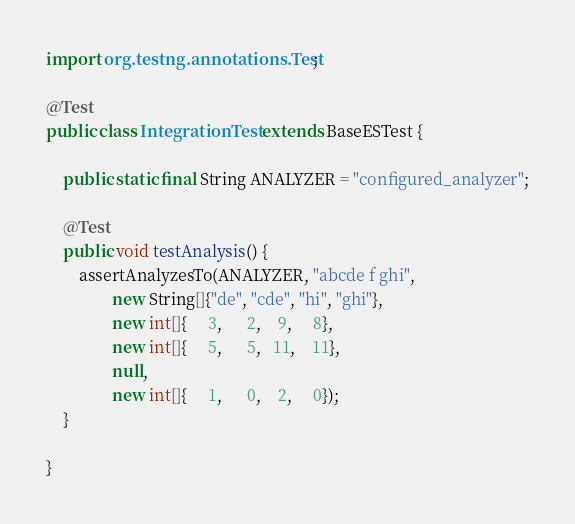<code> <loc_0><loc_0><loc_500><loc_500><_Java_>import org.testng.annotations.Test;

@Test
public class IntegrationTest extends BaseESTest {

    public static final String ANALYZER = "configured_analyzer";

    @Test
    public void testAnalysis() {
        assertAnalyzesTo(ANALYZER, "abcde f ghi",
                new String[]{"de", "cde", "hi", "ghi"},
                new int[]{     3,      2,    9,     8},
                new int[]{     5,      5,   11,    11},
                null,
                new int[]{     1,      0,    2,     0});
    }

}
</code> 